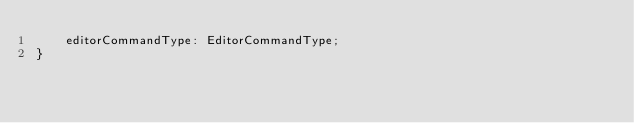<code> <loc_0><loc_0><loc_500><loc_500><_TypeScript_>    editorCommandType: EditorCommandType;
}</code> 